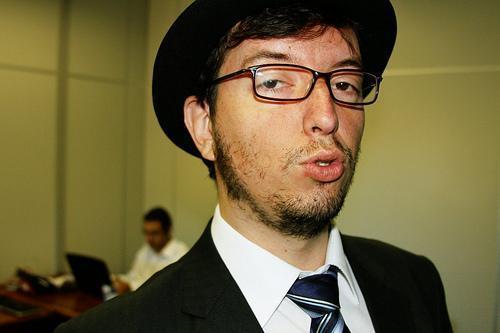How many eyes does this man have?
Give a very brief answer. 2. How many people can be seen?
Give a very brief answer. 2. 